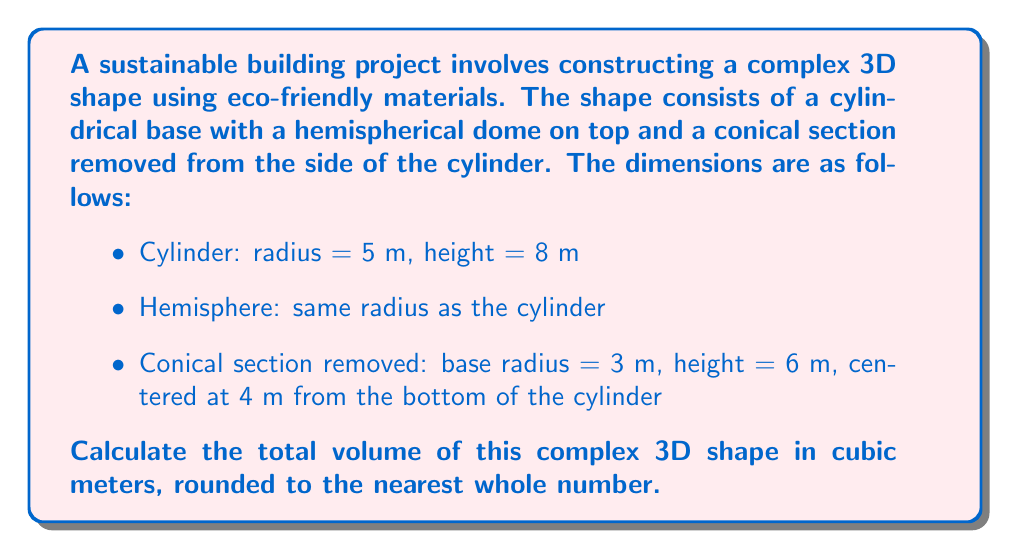What is the answer to this math problem? To solve this problem, we need to calculate the volumes of the individual components and then combine them appropriately. Let's break it down step by step:

1. Volume of the cylinder:
   $$V_{cylinder} = \pi r^2 h = \pi \cdot 5^2 \cdot 8 = 200\pi \text{ m}^3$$

2. Volume of the hemisphere:
   $$V_{hemisphere} = \frac{2}{3}\pi r^3 = \frac{2}{3}\pi \cdot 5^3 = \frac{250}{3}\pi \text{ m}^3$$

3. Volume of the conical section removed:
   We need to use the formula for the volume of a cone, but first, we must calculate the slant height of the cone using the Pythagorean theorem:
   
   $$l = \sqrt{r^2 + h^2} = \sqrt{3^2 + 6^2} = \sqrt{45} = 3\sqrt{5} \text{ m}$$
   
   Now we can calculate the volume:
   $$V_{cone} = \frac{1}{3}\pi r^2 h = \frac{1}{3}\pi \cdot 3^2 \cdot 6 = 18\pi \text{ m}^3$$

4. Total volume:
   To get the total volume, we add the volumes of the cylinder and hemisphere, then subtract the volume of the conical section:
   
   $$V_{total} = V_{cylinder} + V_{hemisphere} - V_{cone}$$
   $$V_{total} = 200\pi + \frac{250}{3}\pi - 18\pi$$
   $$V_{total} = \left(200 + \frac{250}{3} - 18\right)\pi$$
   $$V_{total} = \left(200 + 83.33 - 18\right)\pi$$
   $$V_{total} = 265.33\pi \text{ m}^3$$

5. Converting to a numerical value and rounding:
   $$V_{total} \approx 833.56 \text{ m}^3$$
   
   Rounding to the nearest whole number:
   $$V_{total} \approx 834 \text{ m}^3$$

[asy]
import three;

size(200);
currentprojection=perspective(6,3,2);

// Draw cylinder
draw(surface(circle((0,0,0),5))--surface(circle((0,0,8),5)),palegreen+opacity(0.3));

// Draw hemisphere
draw(shift((0,0,8))*surface(hemisphere(5)),palegreen+opacity(0.3));

// Draw cone (to be subtracted)
draw(shift((0,-5,4))*surface(cone(3,6)),red+opacity(0.5));

// Labels
label("5m", (5.5,0,4));
label("8m", (0,-5.5,4));
label("3m", (0,-8.5,4));
label("6m", (-3,-5,4));

[/asy]
Answer: 834 m³ 